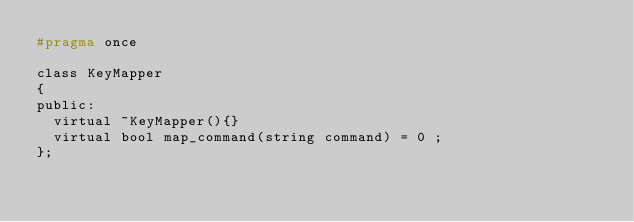Convert code to text. <code><loc_0><loc_0><loc_500><loc_500><_C_>#pragma once

class KeyMapper
{
public:
	virtual ~KeyMapper(){}
	virtual bool map_command(string command) = 0 ;
};</code> 